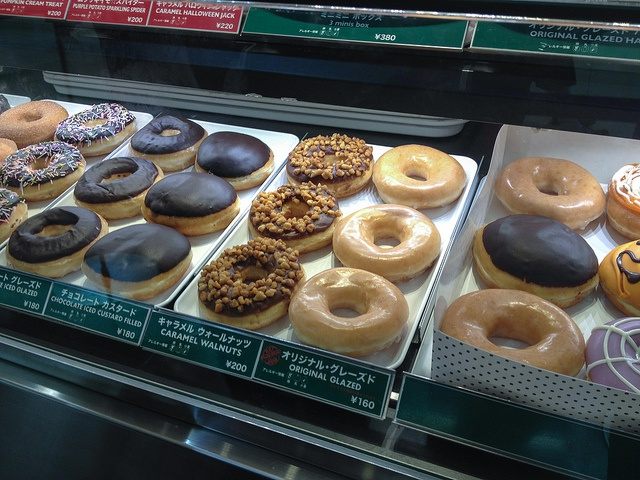Describe the objects in this image and their specific colors. I can see donut in brown, gray, black, darkgray, and white tones, donut in brown, gray, black, and olive tones, donut in brown, olive, tan, and gray tones, donut in brown, gray, and maroon tones, and donut in brown, olive, black, and maroon tones in this image. 